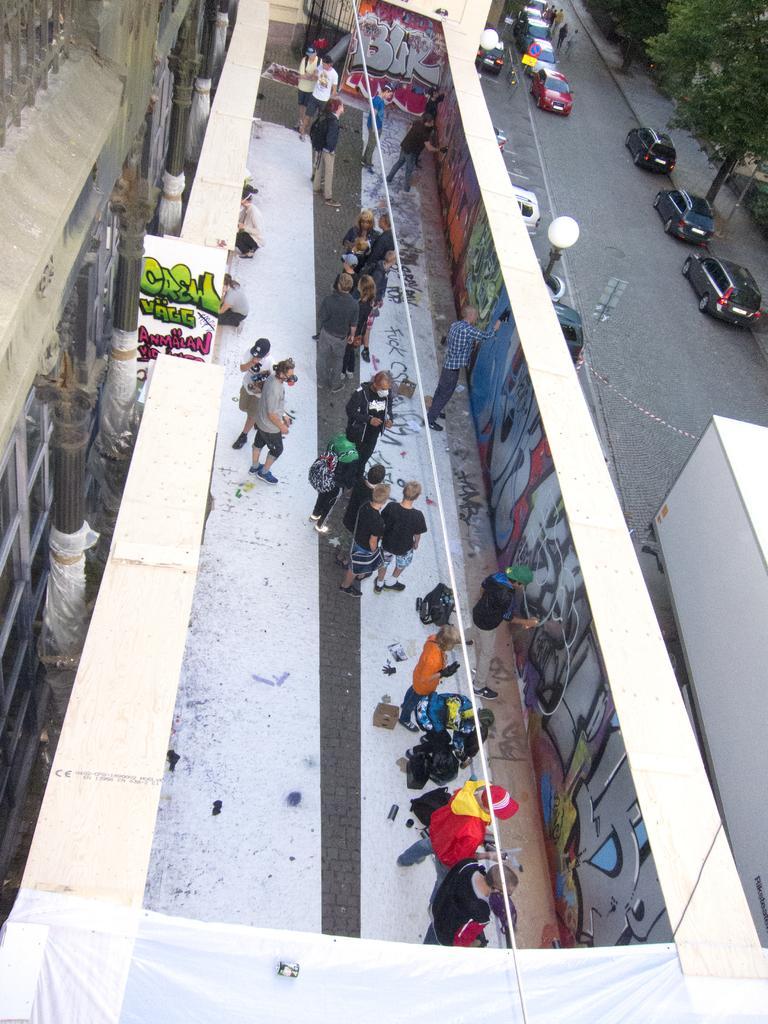Please provide a concise description of this image. In this image we can see one buildings, some pillars in front of the building, two walls, one gate, some people walking on the road, some people standing, some vehicles on the road, some boards with poles, one pole, some vehicles parked near the wall, one object on the white tent, some objects on the floor, one board with text, two people in crouch position, some people are holding some objects, two lights with poles near the wall, some people are painting graffiti, some trees and grass on the ground. 